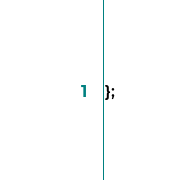<code> <loc_0><loc_0><loc_500><loc_500><_TypeScript_>};
</code> 